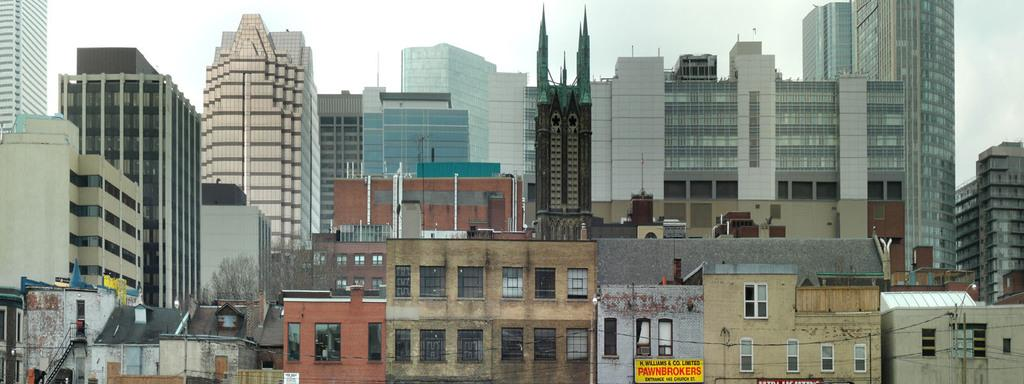<image>
Relay a brief, clear account of the picture shown. a pawn shop that is among many other buildings 